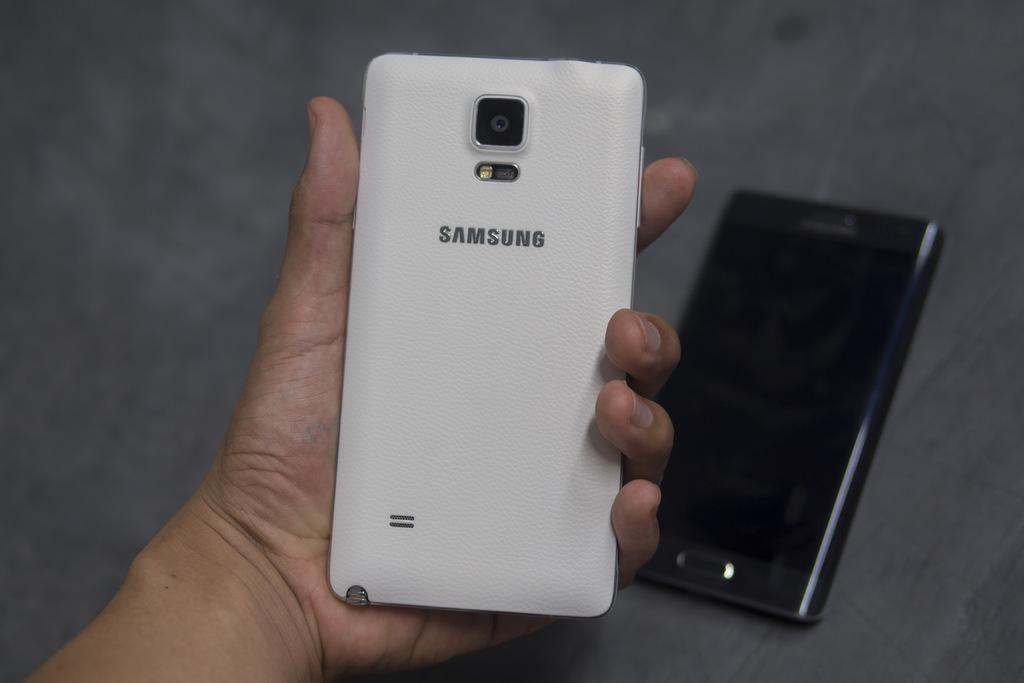<image>
Describe the image concisely. A person is holding a Samsung cell phone in their left hand. 